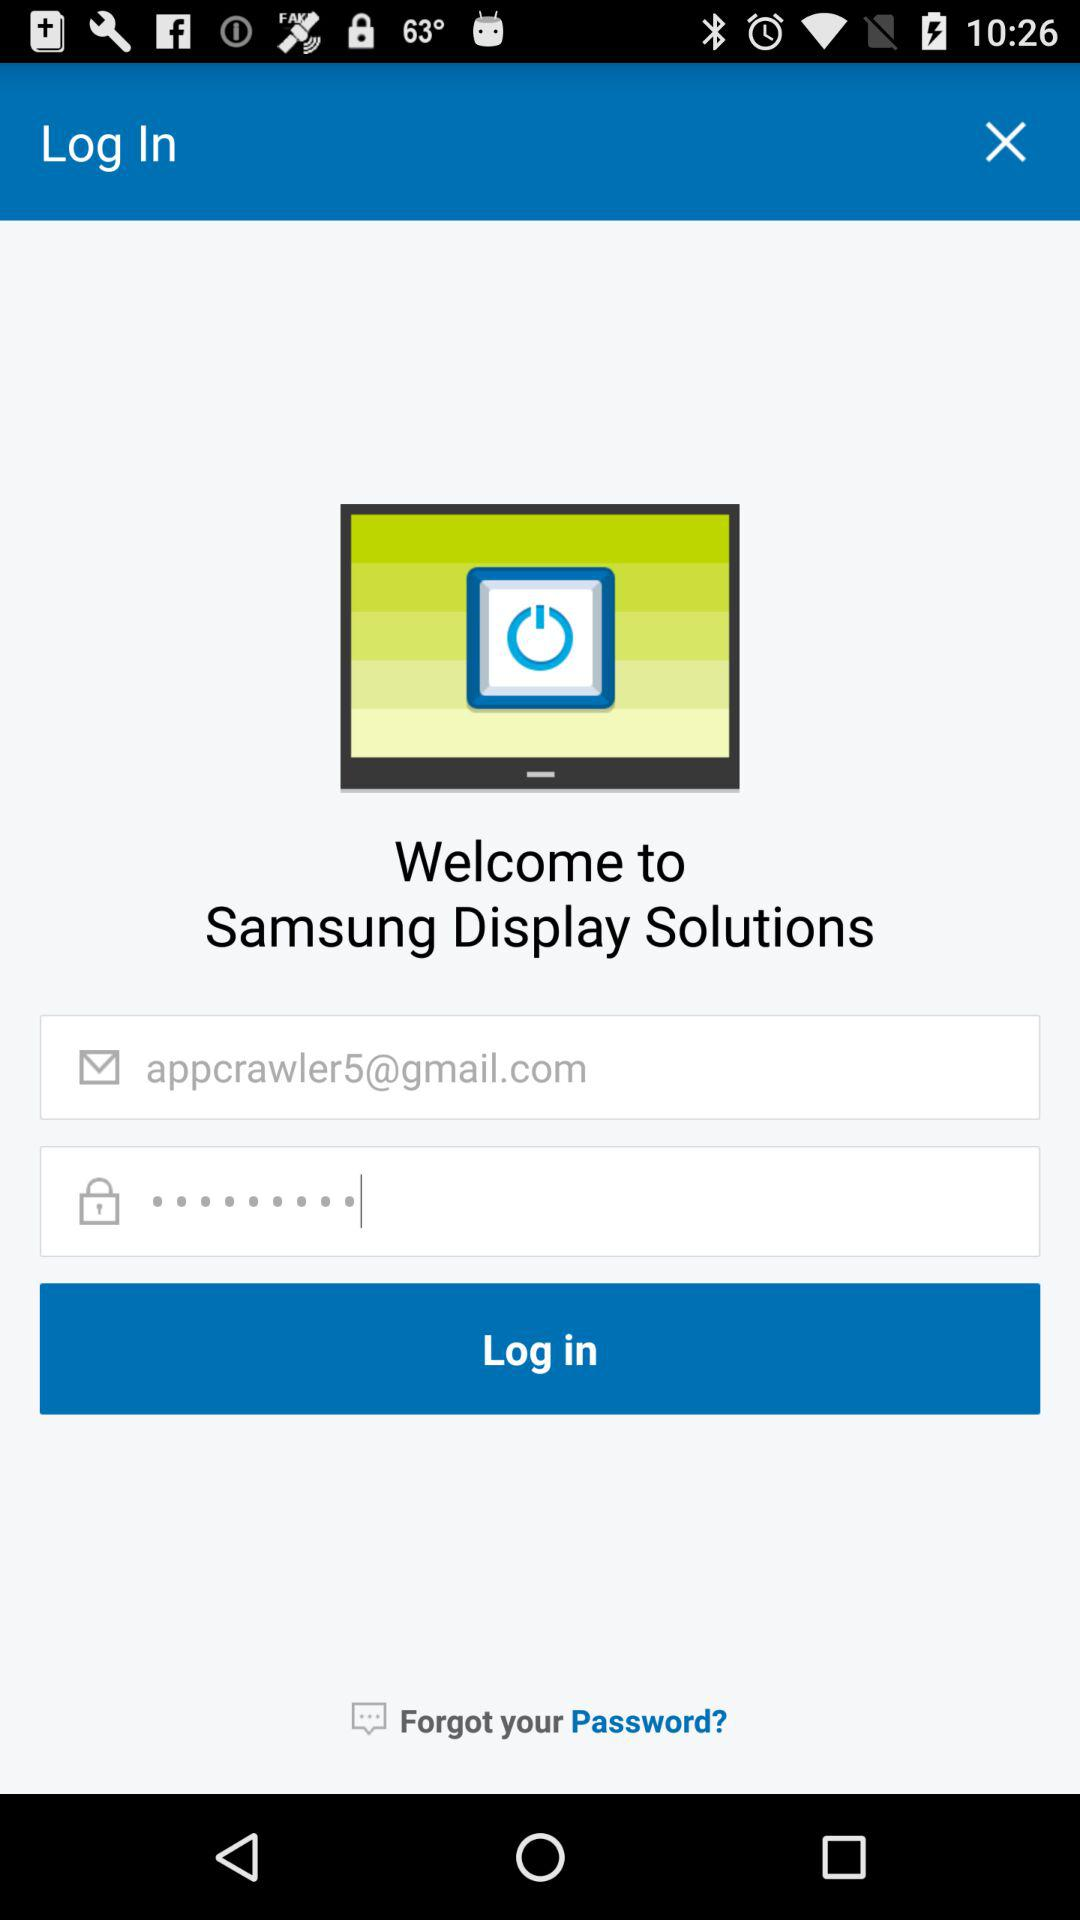Can we reset password?
When the provided information is insufficient, respond with <no answer>. <no answer> 